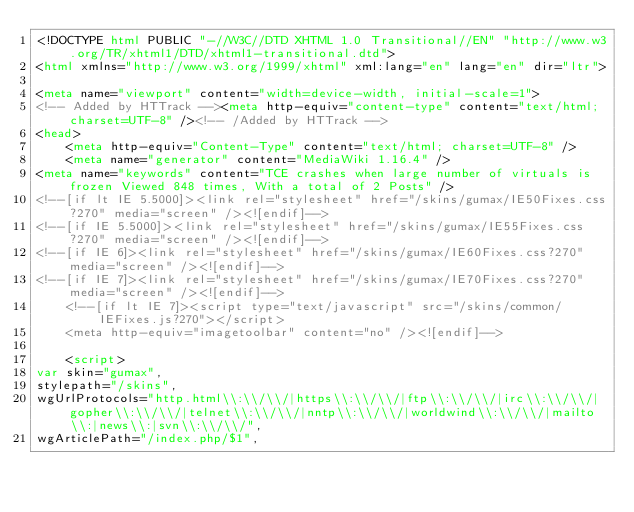Convert code to text. <code><loc_0><loc_0><loc_500><loc_500><_HTML_><!DOCTYPE html PUBLIC "-//W3C//DTD XHTML 1.0 Transitional//EN" "http://www.w3.org/TR/xhtml1/DTD/xhtml1-transitional.dtd">
<html xmlns="http://www.w3.org/1999/xhtml" xml:lang="en" lang="en" dir="ltr">
	
<meta name="viewport" content="width=device-width, initial-scale=1">
<!-- Added by HTTrack --><meta http-equiv="content-type" content="text/html;charset=UTF-8" /><!-- /Added by HTTrack -->
<head>
		<meta http-equiv="Content-Type" content="text/html; charset=UTF-8" />
		<meta name="generator" content="MediaWiki 1.16.4" />
<meta name="keywords" content="TCE crashes when large number of virtuals is frozen Viewed 848 times, With a total of 2 Posts" />
<!--[if lt IE 5.5000]><link rel="stylesheet" href="/skins/gumax/IE50Fixes.css?270" media="screen" /><![endif]-->
<!--[if IE 5.5000]><link rel="stylesheet" href="/skins/gumax/IE55Fixes.css?270" media="screen" /><![endif]-->
<!--[if IE 6]><link rel="stylesheet" href="/skins/gumax/IE60Fixes.css?270" media="screen" /><![endif]-->
<!--[if IE 7]><link rel="stylesheet" href="/skins/gumax/IE70Fixes.css?270" media="screen" /><![endif]-->
		<!--[if lt IE 7]><script type="text/javascript" src="/skins/common/IEFixes.js?270"></script>
		<meta http-equiv="imagetoolbar" content="no" /><![endif]-->

		<script>
var skin="gumax",
stylepath="/skins",
wgUrlProtocols="http.html\\:\\/\\/|https\\:\\/\\/|ftp\\:\\/\\/|irc\\:\\/\\/|gopher\\:\\/\\/|telnet\\:\\/\\/|nntp\\:\\/\\/|worldwind\\:\\/\\/|mailto\\:|news\\:|svn\\:\\/\\/",
wgArticlePath="/index.php/$1",</code> 